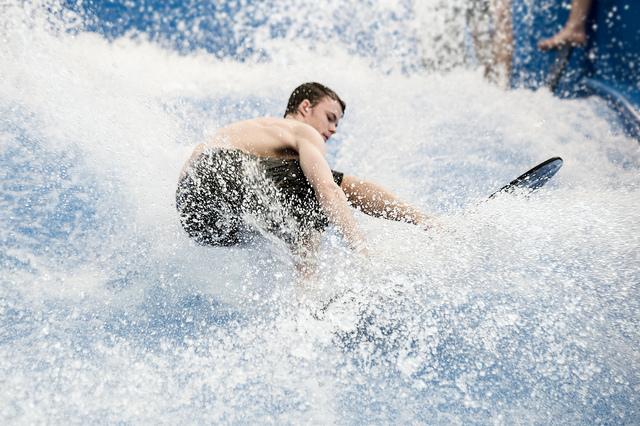Is he wearing a wetsuit?
Keep it brief. No. What is under the boy's armpit?
Give a very brief answer. Hair. What is this young man doing?
Write a very short answer. Surfing. What is the man wearing?
Concise answer only. Swim trunks. 